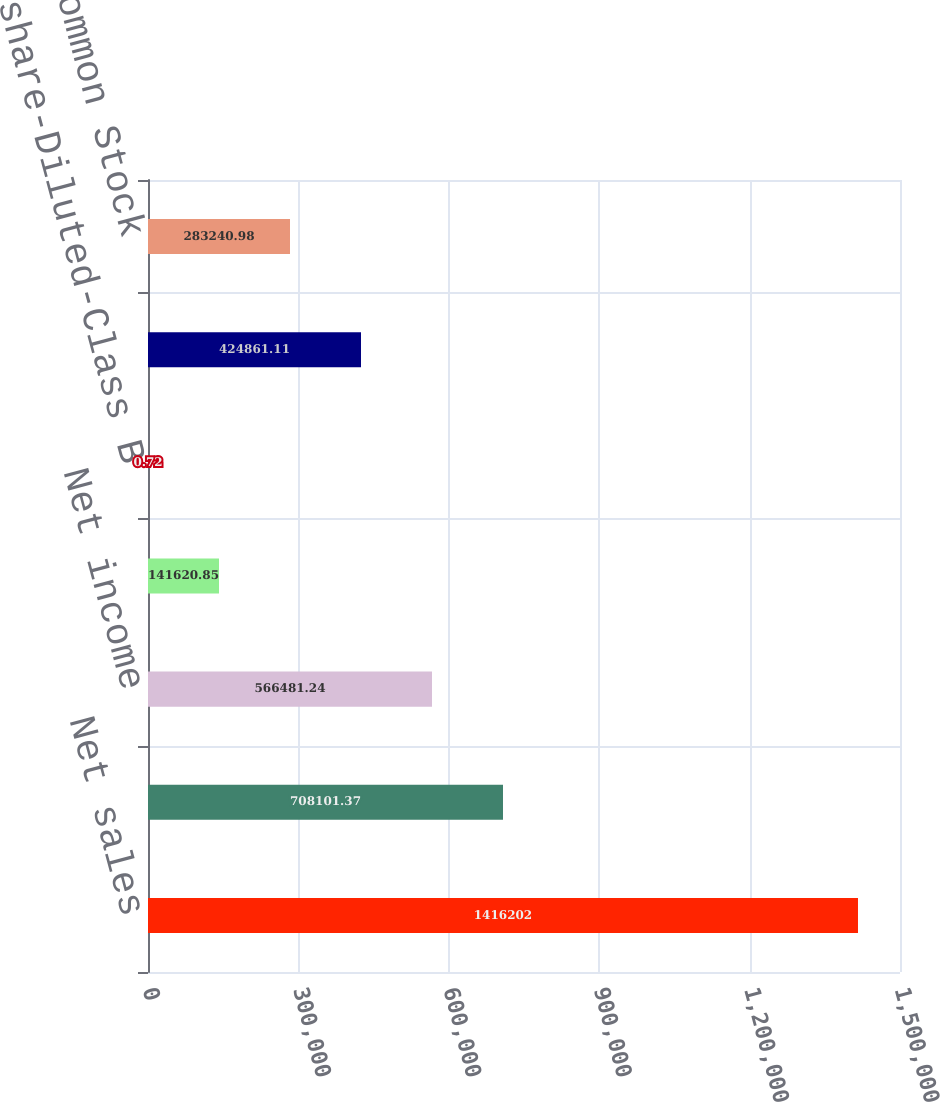Convert chart. <chart><loc_0><loc_0><loc_500><loc_500><bar_chart><fcel>Net sales<fcel>Gross profit<fcel>Net income<fcel>Per share-Basic-Class B Common<fcel>Per share-Diluted-Class B<fcel>Per share-Basic-Common Stock<fcel>Per share-Diluted-Common Stock<nl><fcel>1.4162e+06<fcel>708101<fcel>566481<fcel>141621<fcel>0.72<fcel>424861<fcel>283241<nl></chart> 